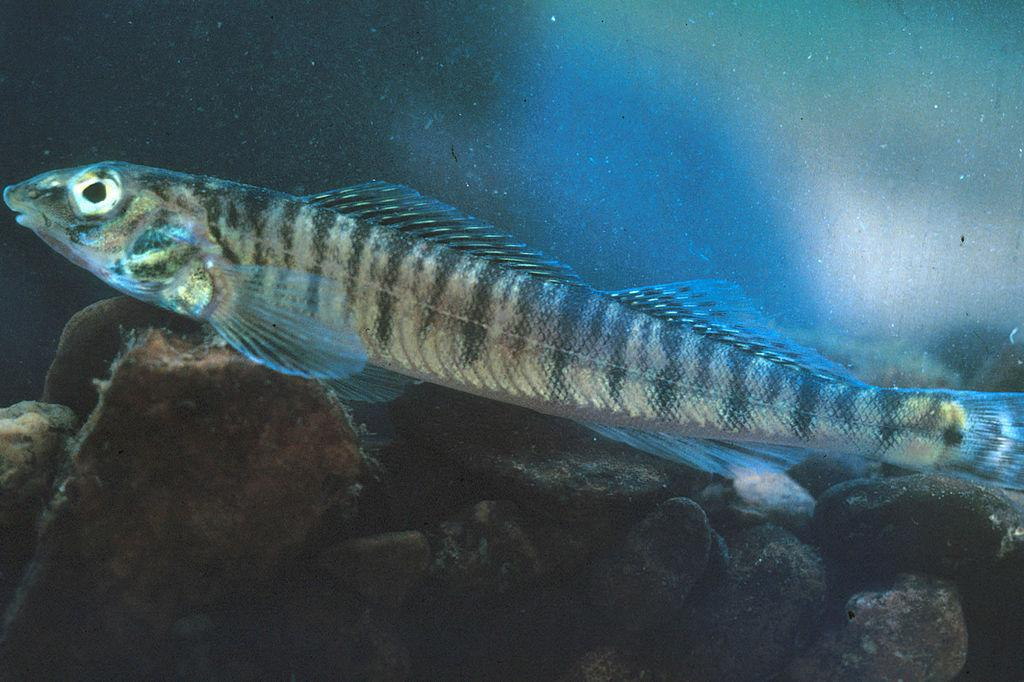What type of animal is in the image? There is a fish in the image. What can be seen in the water with the fish? There are stones in the water in the image. What type of knife is being used to cut the zephyr in the image? There is no knife or zephyr present in the image; it only features a fish and stones in the water. 